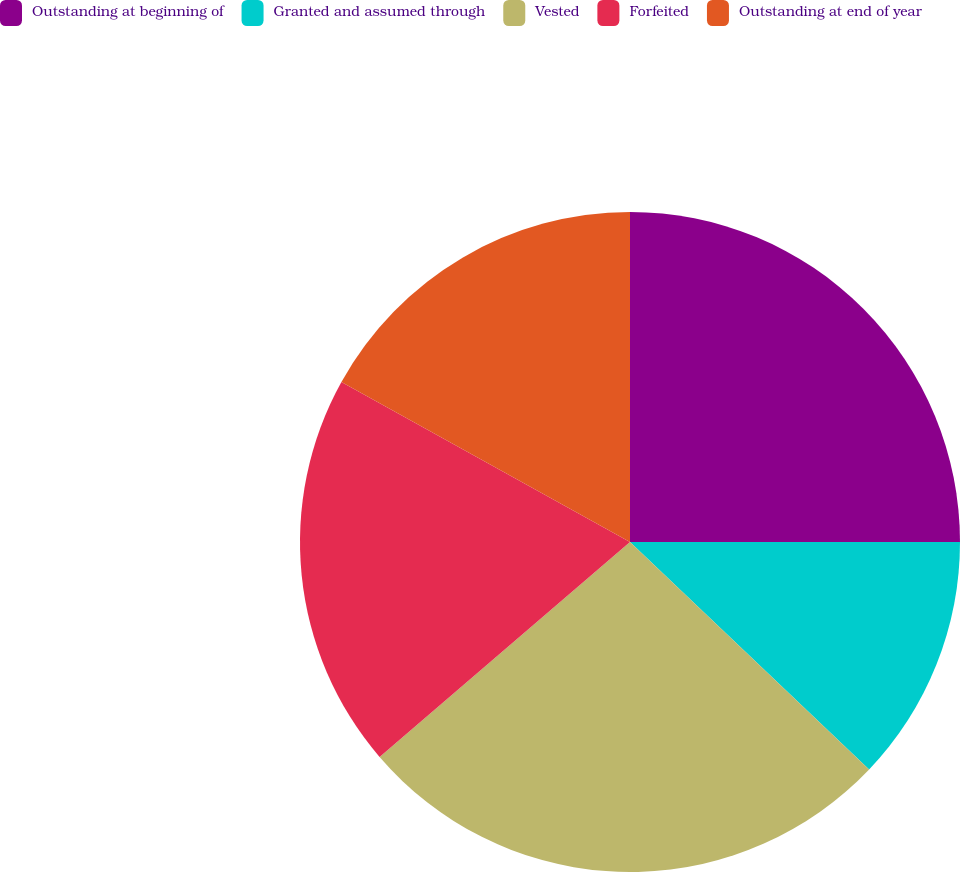Convert chart to OTSL. <chart><loc_0><loc_0><loc_500><loc_500><pie_chart><fcel>Outstanding at beginning of<fcel>Granted and assumed through<fcel>Vested<fcel>Forfeited<fcel>Outstanding at end of year<nl><fcel>25.0%<fcel>12.1%<fcel>26.61%<fcel>19.35%<fcel>16.94%<nl></chart> 